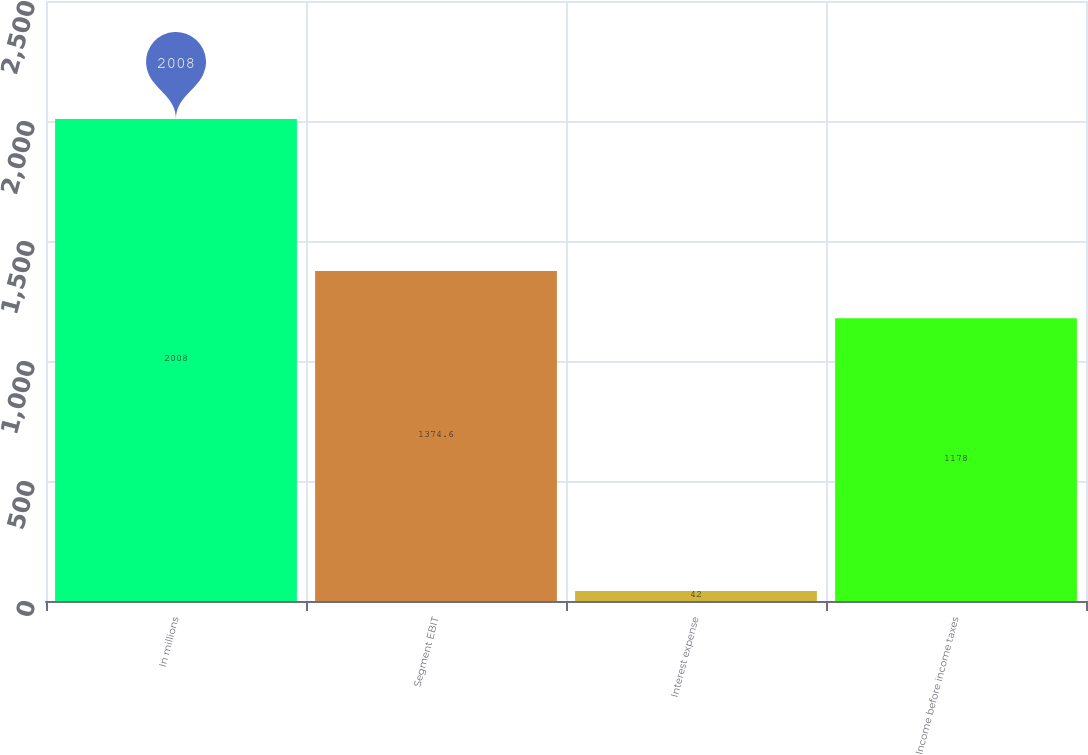<chart> <loc_0><loc_0><loc_500><loc_500><bar_chart><fcel>In millions<fcel>Segment EBIT<fcel>Interest expense<fcel>Income before income taxes<nl><fcel>2008<fcel>1374.6<fcel>42<fcel>1178<nl></chart> 